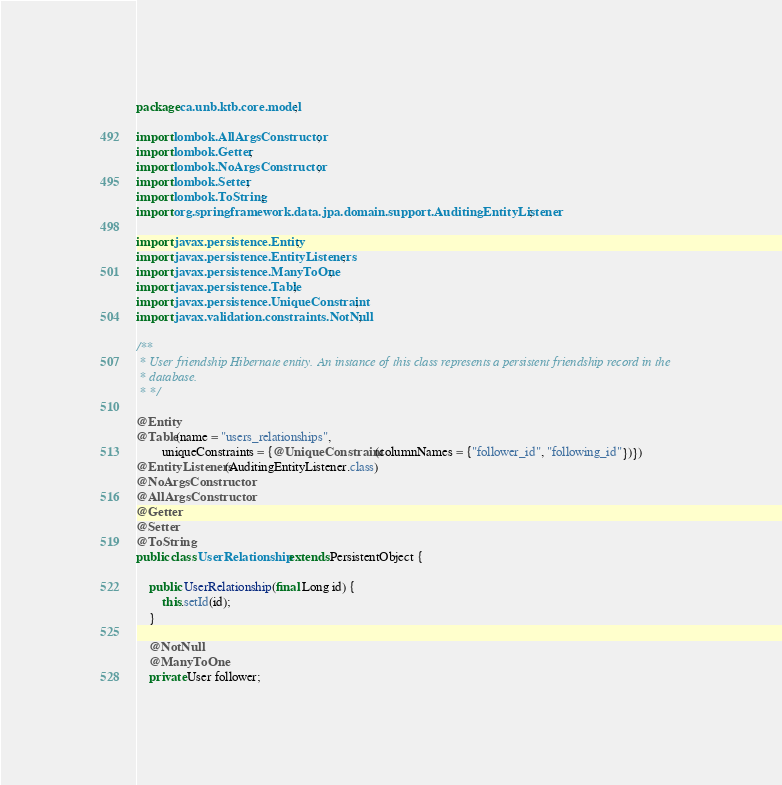<code> <loc_0><loc_0><loc_500><loc_500><_Java_>package ca.unb.ktb.core.model;

import lombok.AllArgsConstructor;
import lombok.Getter;
import lombok.NoArgsConstructor;
import lombok.Setter;
import lombok.ToString;
import org.springframework.data.jpa.domain.support.AuditingEntityListener;

import javax.persistence.Entity;
import javax.persistence.EntityListeners;
import javax.persistence.ManyToOne;
import javax.persistence.Table;
import javax.persistence.UniqueConstraint;
import javax.validation.constraints.NotNull;

/**
 * User friendship Hibernate entity. An instance of this class represents a persistent friendship record in the
 * database.
 * */

@Entity
@Table(name = "users_relationships",
        uniqueConstraints = {@UniqueConstraint(columnNames = {"follower_id", "following_id"})})
@EntityListeners(AuditingEntityListener.class)
@NoArgsConstructor
@AllArgsConstructor
@Getter
@Setter
@ToString
public class UserRelationship extends PersistentObject {

    public UserRelationship(final Long id) {
        this.setId(id);
    }

    @NotNull
    @ManyToOne
    private User follower;
</code> 